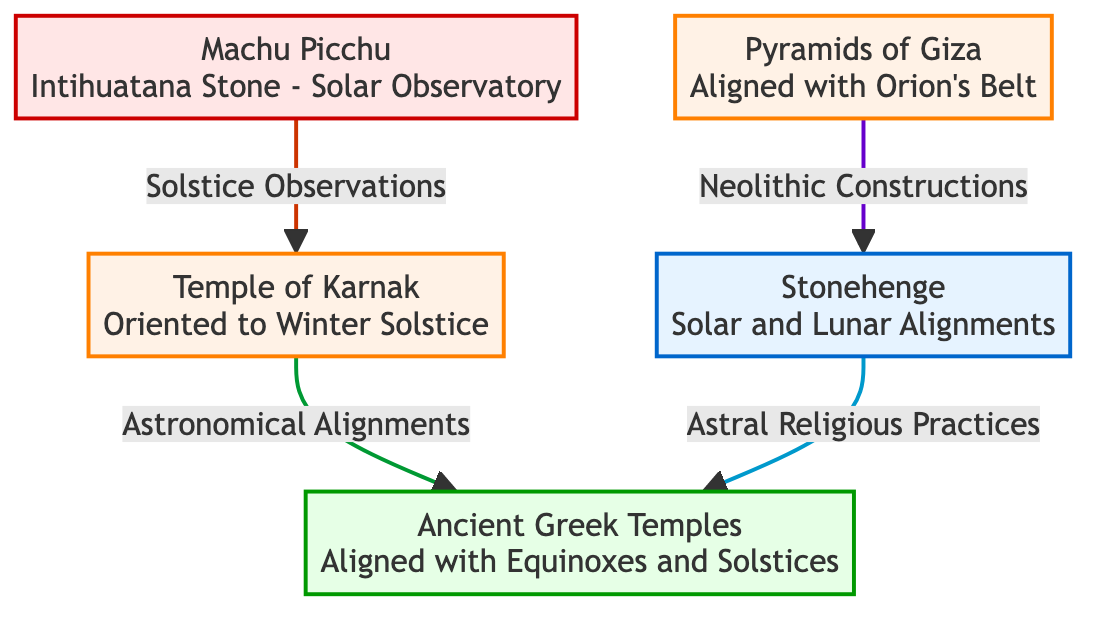What structure is aligned with Orion's Belt? The diagram shows that the Pyramids of Giza are aligned with Orion's Belt, as indicated by the connection to that node.
Answer: Pyramids of Giza How many architectural designs are featured in the diagram? The diagram includes five nodes representing different architectural designs, each showing influences from astronomy.
Answer: 5 Which civilization is associated with Machu Picchu? The diagram labels Machu Picchu as connected to the Inca civilization, which is clearly indicated through the color coding of the node.
Answer: Inca What type of alignments are Stonehenge related to? The diagram specifies that Stonehenge is related to solar and lunar alignments, indicating its astronomical significance in terms of celestial events.
Answer: Solar and Lunar Alignments What astronomical event is the Temple of Karnak oriented to? According to the diagram, the Temple of Karnak is oriented to the Winter Solstice, linking architectural design to this specific astronomical event.
Answer: Winter Solstice Which ancient structure is linked to solstice observations? The diagram shows that Machu Picchu is linked to solstice observations, highlighting its purpose as an astronomical observatory.
Answer: Machu Picchu What connects the Pyramids of Giza and Stonehenge? The diagram indicates that both structures are connected through "Neolithic Constructions", suggesting a shared historical and cultural background.
Answer: Neolithic Constructions What aligns Ancient Greek Temples with other buildings? The diagram illustrates that Ancient Greek Temples are aligned with both equinoxes and solstices, signifying their architectural planning in relation to celestial events.
Answer: Equinoxes and Solstices How is the relationship between the Temple of Karnak and Ancient Greek Temples characterized? The diagram characterizes their relationship through the connection marked as "Astronomical Alignments", indicating a thematic similarity in their designs.
Answer: Astronomical Alignments 